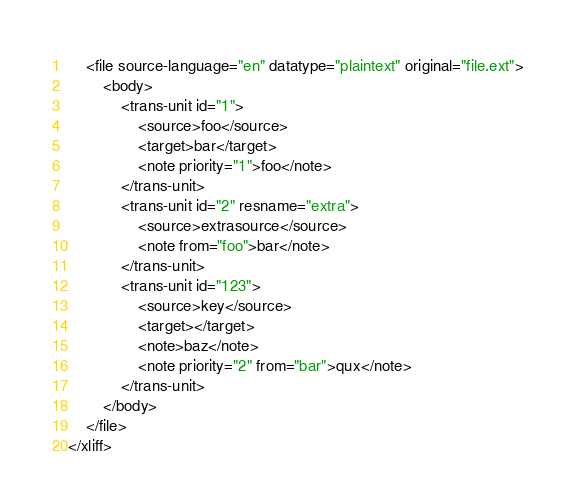<code> <loc_0><loc_0><loc_500><loc_500><_XML_>    <file source-language="en" datatype="plaintext" original="file.ext">
        <body>
            <trans-unit id="1">
                <source>foo</source>
                <target>bar</target>
                <note priority="1">foo</note>
            </trans-unit>
            <trans-unit id="2" resname="extra">
                <source>extrasource</source>
                <note from="foo">bar</note>
            </trans-unit>
            <trans-unit id="123">
                <source>key</source>
                <target></target>
                <note>baz</note>
                <note priority="2" from="bar">qux</note>
            </trans-unit>
        </body>
    </file>
</xliff>
</code> 